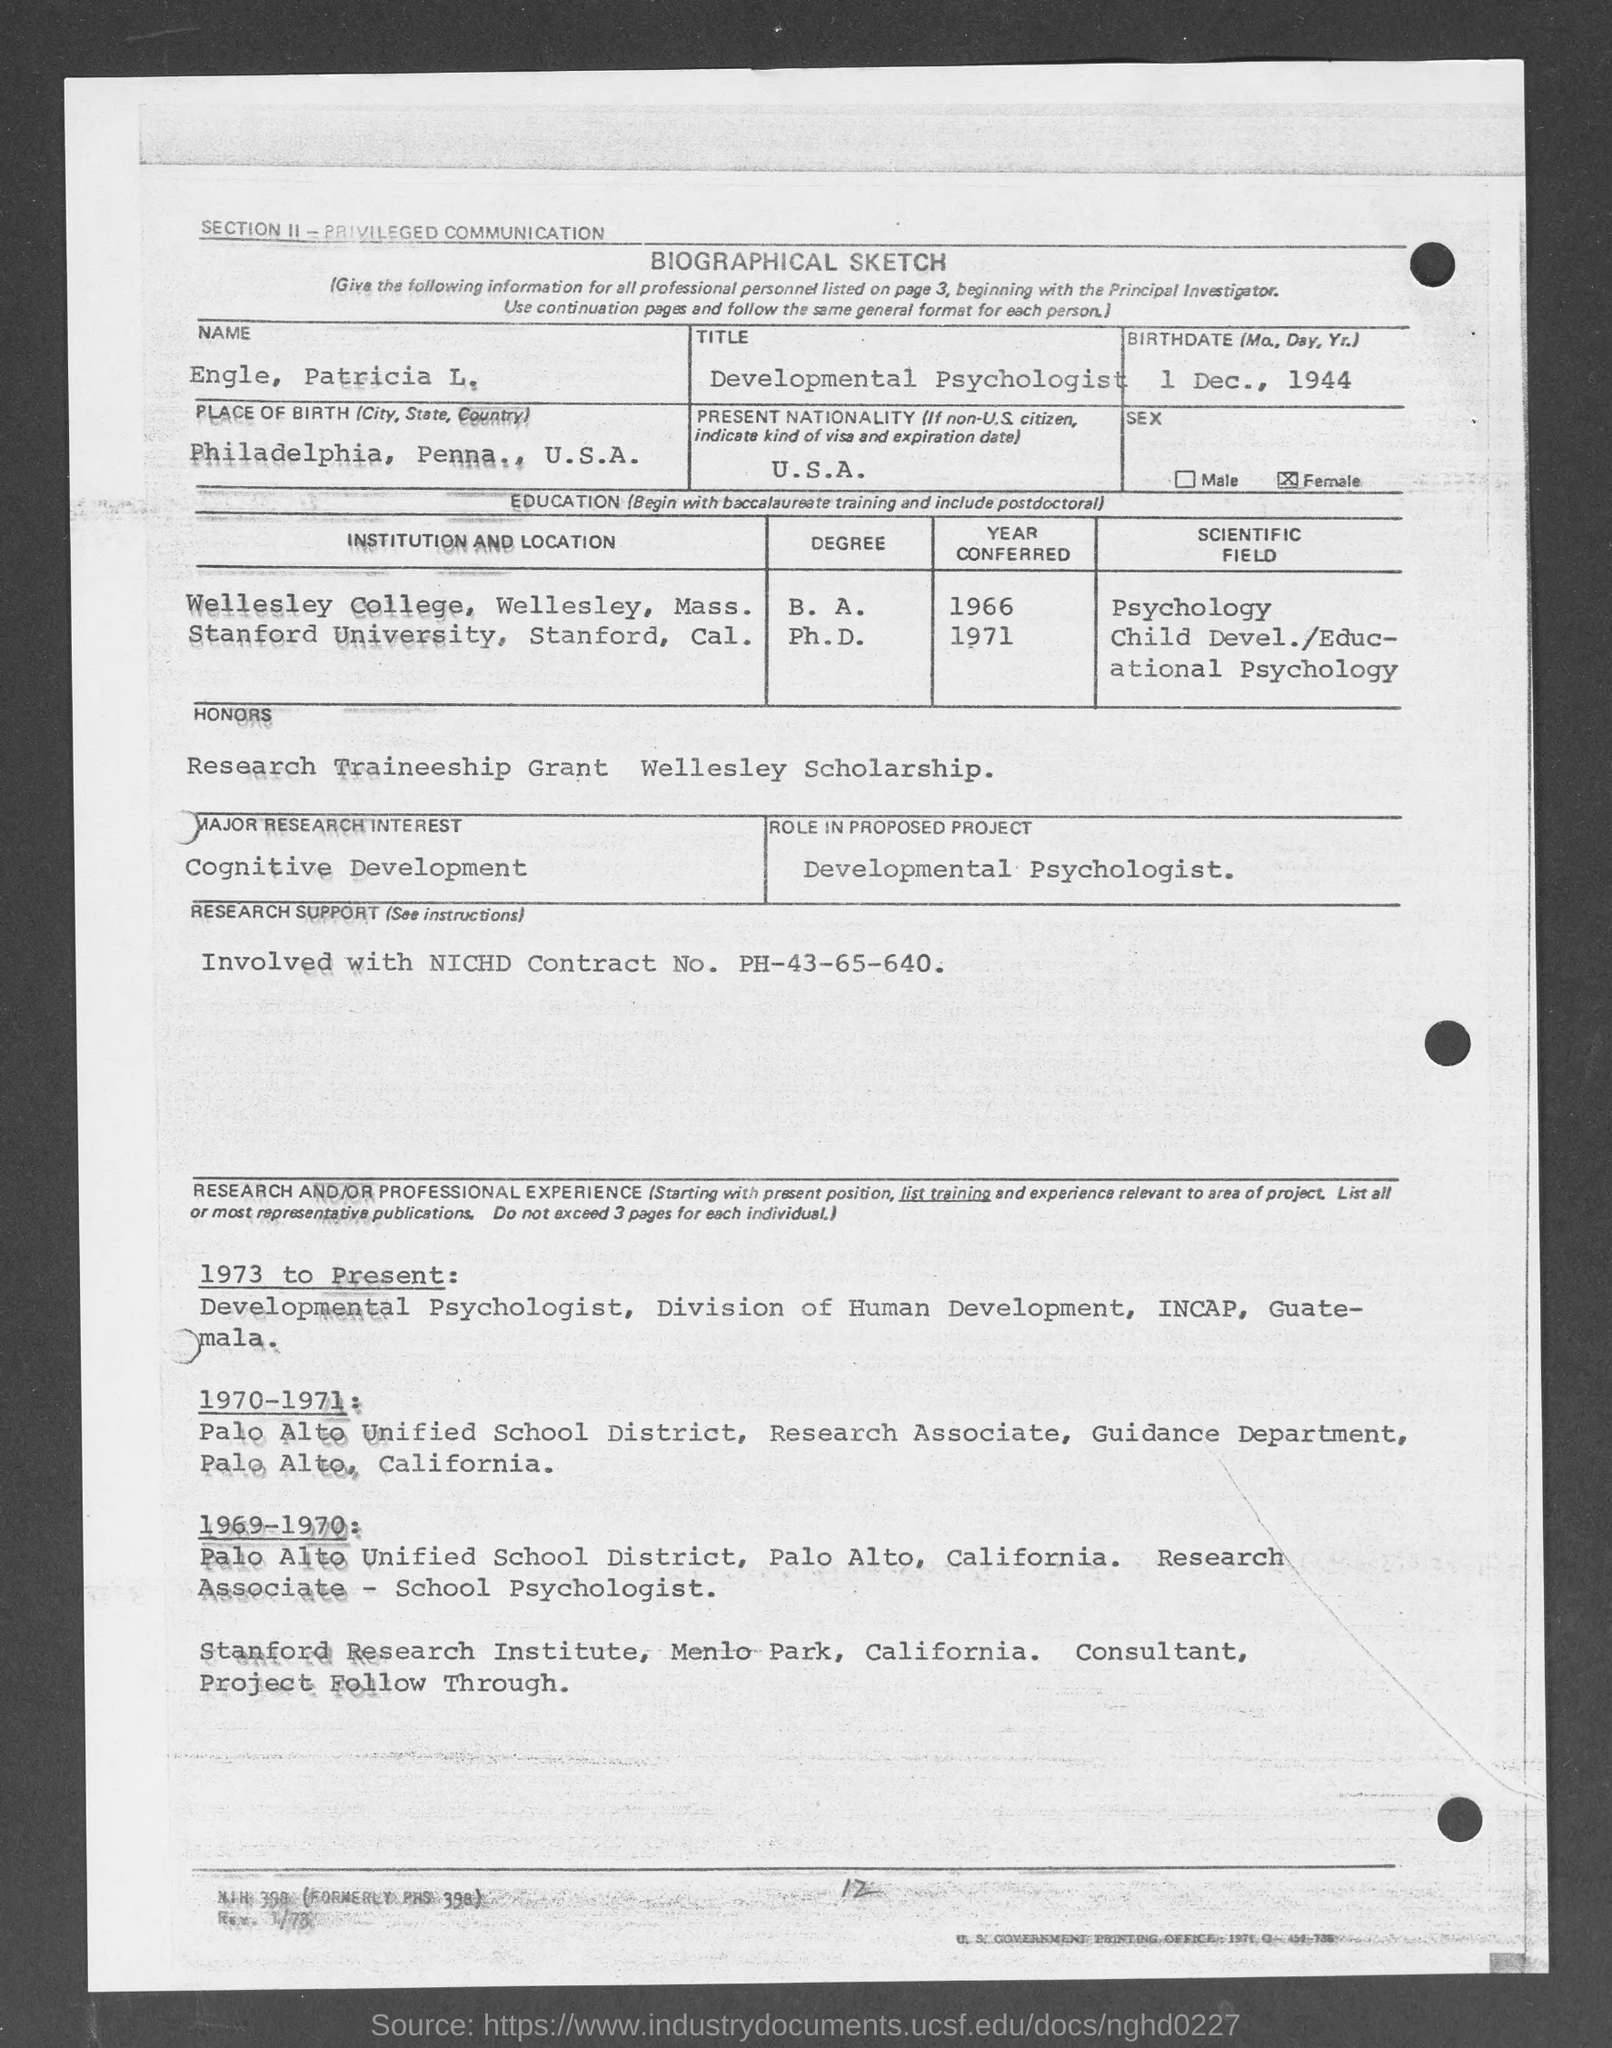What is the Title of the document?
Provide a succinct answer. BIOGRAPHICAL SKETCH. What is the Name?
Your answer should be compact. Engle, Patricia L. What is the Birthdate?
Offer a very short reply. 1 Dec., 1944. What is the Place of Birth?
Your response must be concise. Philadelphia, Penna., U.S.A. What is the Present Nationality?
Your answer should be very brief. U.S.A. What is the Major REsearch Interest?
Ensure brevity in your answer.  Cognitive Development. What is the Role in proposed project?
Ensure brevity in your answer.  Developmental Psychologist. When was she in Wellesley College, Wellesley, Mass.?
Ensure brevity in your answer.  1966. When was she in Stanford University, Stanford, Cal.?
Provide a succinct answer. 1971. 